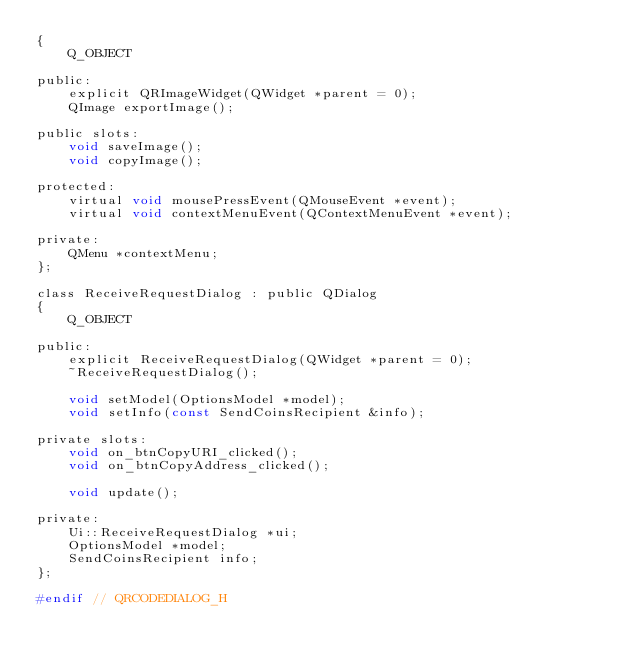Convert code to text. <code><loc_0><loc_0><loc_500><loc_500><_C_>{
    Q_OBJECT

public:
    explicit QRImageWidget(QWidget *parent = 0);
    QImage exportImage();

public slots:
    void saveImage();
    void copyImage();

protected:
    virtual void mousePressEvent(QMouseEvent *event);
    virtual void contextMenuEvent(QContextMenuEvent *event);

private:
    QMenu *contextMenu;
};

class ReceiveRequestDialog : public QDialog
{
    Q_OBJECT

public:
    explicit ReceiveRequestDialog(QWidget *parent = 0);
    ~ReceiveRequestDialog();

    void setModel(OptionsModel *model);
    void setInfo(const SendCoinsRecipient &info);

private slots:
    void on_btnCopyURI_clicked();
    void on_btnCopyAddress_clicked();

    void update();

private:
    Ui::ReceiveRequestDialog *ui;
    OptionsModel *model;
    SendCoinsRecipient info;
};

#endif // QRCODEDIALOG_H
</code> 